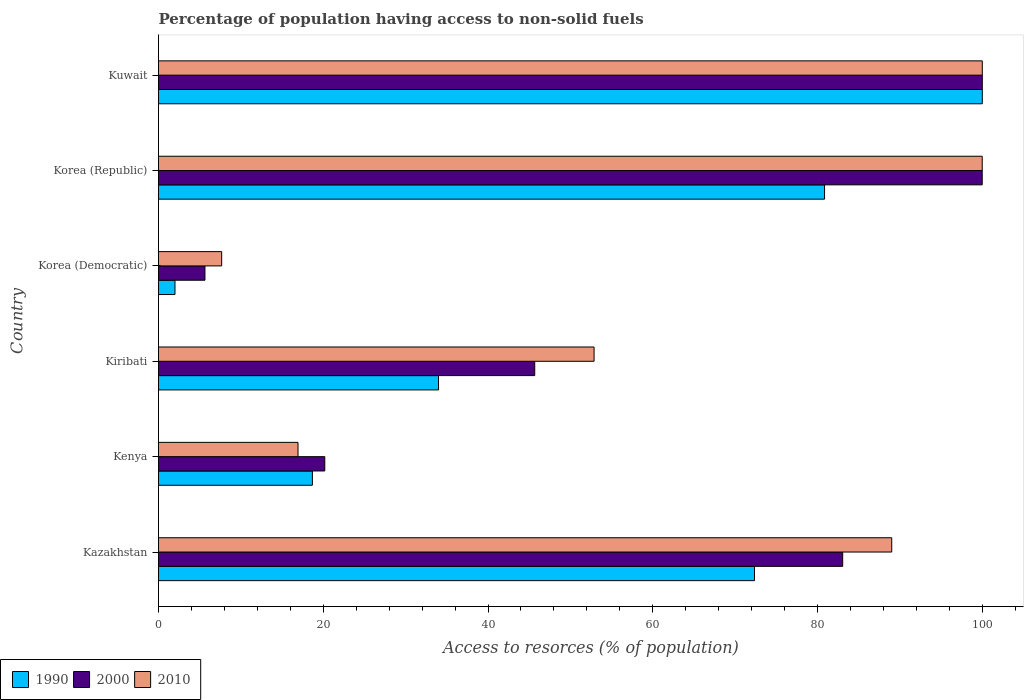How many different coloured bars are there?
Your answer should be compact. 3. How many groups of bars are there?
Your answer should be compact. 6. Are the number of bars on each tick of the Y-axis equal?
Offer a terse response. Yes. How many bars are there on the 2nd tick from the top?
Your answer should be very brief. 3. How many bars are there on the 1st tick from the bottom?
Offer a terse response. 3. What is the label of the 4th group of bars from the top?
Your answer should be very brief. Kiribati. In how many cases, is the number of bars for a given country not equal to the number of legend labels?
Offer a very short reply. 0. What is the percentage of population having access to non-solid fuels in 1990 in Kiribati?
Offer a terse response. 33.99. Across all countries, what is the maximum percentage of population having access to non-solid fuels in 1990?
Give a very brief answer. 100. Across all countries, what is the minimum percentage of population having access to non-solid fuels in 1990?
Give a very brief answer. 2. In which country was the percentage of population having access to non-solid fuels in 2000 maximum?
Make the answer very short. Kuwait. In which country was the percentage of population having access to non-solid fuels in 2000 minimum?
Ensure brevity in your answer.  Korea (Democratic). What is the total percentage of population having access to non-solid fuels in 2000 in the graph?
Make the answer very short. 354.53. What is the difference between the percentage of population having access to non-solid fuels in 2010 in Kazakhstan and that in Kiribati?
Offer a terse response. 36.13. What is the difference between the percentage of population having access to non-solid fuels in 1990 in Korea (Democratic) and the percentage of population having access to non-solid fuels in 2010 in Kuwait?
Keep it short and to the point. -98. What is the average percentage of population having access to non-solid fuels in 2010 per country?
Your response must be concise. 61.08. In how many countries, is the percentage of population having access to non-solid fuels in 2010 greater than 96 %?
Give a very brief answer. 2. What is the ratio of the percentage of population having access to non-solid fuels in 2000 in Korea (Republic) to that in Kuwait?
Offer a terse response. 1. Is the difference between the percentage of population having access to non-solid fuels in 2010 in Kiribati and Korea (Republic) greater than the difference between the percentage of population having access to non-solid fuels in 2000 in Kiribati and Korea (Republic)?
Keep it short and to the point. Yes. What is the difference between the highest and the second highest percentage of population having access to non-solid fuels in 1990?
Keep it short and to the point. 19.15. What is the difference between the highest and the lowest percentage of population having access to non-solid fuels in 2000?
Offer a terse response. 94.36. Is the sum of the percentage of population having access to non-solid fuels in 2010 in Kazakhstan and Korea (Democratic) greater than the maximum percentage of population having access to non-solid fuels in 1990 across all countries?
Your response must be concise. No. What is the difference between two consecutive major ticks on the X-axis?
Give a very brief answer. 20. How many legend labels are there?
Keep it short and to the point. 3. What is the title of the graph?
Offer a terse response. Percentage of population having access to non-solid fuels. What is the label or title of the X-axis?
Keep it short and to the point. Access to resorces (% of population). What is the label or title of the Y-axis?
Provide a succinct answer. Country. What is the Access to resorces (% of population) in 1990 in Kazakhstan?
Your answer should be compact. 72.35. What is the Access to resorces (% of population) of 2000 in Kazakhstan?
Ensure brevity in your answer.  83.05. What is the Access to resorces (% of population) of 2010 in Kazakhstan?
Provide a succinct answer. 89.01. What is the Access to resorces (% of population) of 1990 in Kenya?
Keep it short and to the point. 18.68. What is the Access to resorces (% of population) in 2000 in Kenya?
Provide a short and direct response. 20.18. What is the Access to resorces (% of population) of 2010 in Kenya?
Offer a very short reply. 16.93. What is the Access to resorces (% of population) of 1990 in Kiribati?
Provide a short and direct response. 33.99. What is the Access to resorces (% of population) in 2000 in Kiribati?
Make the answer very short. 45.67. What is the Access to resorces (% of population) of 2010 in Kiribati?
Make the answer very short. 52.87. What is the Access to resorces (% of population) in 1990 in Korea (Democratic)?
Offer a very short reply. 2. What is the Access to resorces (% of population) in 2000 in Korea (Democratic)?
Provide a short and direct response. 5.64. What is the Access to resorces (% of population) of 2010 in Korea (Democratic)?
Give a very brief answer. 7.67. What is the Access to resorces (% of population) of 1990 in Korea (Republic)?
Ensure brevity in your answer.  80.85. What is the Access to resorces (% of population) in 2000 in Korea (Republic)?
Your response must be concise. 99.99. What is the Access to resorces (% of population) in 2010 in Korea (Republic)?
Provide a short and direct response. 99.99. Across all countries, what is the minimum Access to resorces (% of population) of 1990?
Give a very brief answer. 2. Across all countries, what is the minimum Access to resorces (% of population) of 2000?
Make the answer very short. 5.64. Across all countries, what is the minimum Access to resorces (% of population) of 2010?
Provide a short and direct response. 7.67. What is the total Access to resorces (% of population) of 1990 in the graph?
Provide a succinct answer. 307.86. What is the total Access to resorces (% of population) of 2000 in the graph?
Provide a short and direct response. 354.53. What is the total Access to resorces (% of population) of 2010 in the graph?
Offer a very short reply. 366.47. What is the difference between the Access to resorces (% of population) of 1990 in Kazakhstan and that in Kenya?
Provide a succinct answer. 53.67. What is the difference between the Access to resorces (% of population) of 2000 in Kazakhstan and that in Kenya?
Keep it short and to the point. 62.87. What is the difference between the Access to resorces (% of population) of 2010 in Kazakhstan and that in Kenya?
Your answer should be compact. 72.07. What is the difference between the Access to resorces (% of population) in 1990 in Kazakhstan and that in Kiribati?
Provide a short and direct response. 38.36. What is the difference between the Access to resorces (% of population) in 2000 in Kazakhstan and that in Kiribati?
Make the answer very short. 37.38. What is the difference between the Access to resorces (% of population) of 2010 in Kazakhstan and that in Kiribati?
Give a very brief answer. 36.13. What is the difference between the Access to resorces (% of population) of 1990 in Kazakhstan and that in Korea (Democratic)?
Offer a terse response. 70.35. What is the difference between the Access to resorces (% of population) of 2000 in Kazakhstan and that in Korea (Democratic)?
Your answer should be compact. 77.41. What is the difference between the Access to resorces (% of population) of 2010 in Kazakhstan and that in Korea (Democratic)?
Provide a short and direct response. 81.34. What is the difference between the Access to resorces (% of population) in 1990 in Kazakhstan and that in Korea (Republic)?
Make the answer very short. -8.5. What is the difference between the Access to resorces (% of population) of 2000 in Kazakhstan and that in Korea (Republic)?
Provide a short and direct response. -16.94. What is the difference between the Access to resorces (% of population) of 2010 in Kazakhstan and that in Korea (Republic)?
Your answer should be very brief. -10.98. What is the difference between the Access to resorces (% of population) in 1990 in Kazakhstan and that in Kuwait?
Provide a short and direct response. -27.65. What is the difference between the Access to resorces (% of population) in 2000 in Kazakhstan and that in Kuwait?
Give a very brief answer. -16.95. What is the difference between the Access to resorces (% of population) of 2010 in Kazakhstan and that in Kuwait?
Give a very brief answer. -10.99. What is the difference between the Access to resorces (% of population) in 1990 in Kenya and that in Kiribati?
Offer a terse response. -15.31. What is the difference between the Access to resorces (% of population) of 2000 in Kenya and that in Kiribati?
Keep it short and to the point. -25.48. What is the difference between the Access to resorces (% of population) in 2010 in Kenya and that in Kiribati?
Offer a very short reply. -35.94. What is the difference between the Access to resorces (% of population) of 1990 in Kenya and that in Korea (Democratic)?
Your answer should be compact. 16.68. What is the difference between the Access to resorces (% of population) of 2000 in Kenya and that in Korea (Democratic)?
Your answer should be very brief. 14.55. What is the difference between the Access to resorces (% of population) in 2010 in Kenya and that in Korea (Democratic)?
Keep it short and to the point. 9.27. What is the difference between the Access to resorces (% of population) in 1990 in Kenya and that in Korea (Republic)?
Your response must be concise. -62.17. What is the difference between the Access to resorces (% of population) of 2000 in Kenya and that in Korea (Republic)?
Keep it short and to the point. -79.81. What is the difference between the Access to resorces (% of population) in 2010 in Kenya and that in Korea (Republic)?
Your response must be concise. -83.06. What is the difference between the Access to resorces (% of population) of 1990 in Kenya and that in Kuwait?
Your response must be concise. -81.32. What is the difference between the Access to resorces (% of population) of 2000 in Kenya and that in Kuwait?
Your answer should be compact. -79.82. What is the difference between the Access to resorces (% of population) in 2010 in Kenya and that in Kuwait?
Provide a short and direct response. -83.07. What is the difference between the Access to resorces (% of population) of 1990 in Kiribati and that in Korea (Democratic)?
Make the answer very short. 31.99. What is the difference between the Access to resorces (% of population) in 2000 in Kiribati and that in Korea (Democratic)?
Ensure brevity in your answer.  40.03. What is the difference between the Access to resorces (% of population) in 2010 in Kiribati and that in Korea (Democratic)?
Your answer should be very brief. 45.21. What is the difference between the Access to resorces (% of population) in 1990 in Kiribati and that in Korea (Republic)?
Offer a terse response. -46.86. What is the difference between the Access to resorces (% of population) in 2000 in Kiribati and that in Korea (Republic)?
Offer a terse response. -54.32. What is the difference between the Access to resorces (% of population) in 2010 in Kiribati and that in Korea (Republic)?
Provide a short and direct response. -47.12. What is the difference between the Access to resorces (% of population) in 1990 in Kiribati and that in Kuwait?
Keep it short and to the point. -66.01. What is the difference between the Access to resorces (% of population) of 2000 in Kiribati and that in Kuwait?
Give a very brief answer. -54.33. What is the difference between the Access to resorces (% of population) of 2010 in Kiribati and that in Kuwait?
Offer a terse response. -47.13. What is the difference between the Access to resorces (% of population) of 1990 in Korea (Democratic) and that in Korea (Republic)?
Your answer should be compact. -78.85. What is the difference between the Access to resorces (% of population) of 2000 in Korea (Democratic) and that in Korea (Republic)?
Ensure brevity in your answer.  -94.35. What is the difference between the Access to resorces (% of population) of 2010 in Korea (Democratic) and that in Korea (Republic)?
Your answer should be very brief. -92.32. What is the difference between the Access to resorces (% of population) in 1990 in Korea (Democratic) and that in Kuwait?
Give a very brief answer. -98. What is the difference between the Access to resorces (% of population) in 2000 in Korea (Democratic) and that in Kuwait?
Offer a very short reply. -94.36. What is the difference between the Access to resorces (% of population) of 2010 in Korea (Democratic) and that in Kuwait?
Offer a very short reply. -92.33. What is the difference between the Access to resorces (% of population) in 1990 in Korea (Republic) and that in Kuwait?
Your answer should be compact. -19.15. What is the difference between the Access to resorces (% of population) in 2000 in Korea (Republic) and that in Kuwait?
Your answer should be compact. -0.01. What is the difference between the Access to resorces (% of population) in 2010 in Korea (Republic) and that in Kuwait?
Keep it short and to the point. -0.01. What is the difference between the Access to resorces (% of population) of 1990 in Kazakhstan and the Access to resorces (% of population) of 2000 in Kenya?
Ensure brevity in your answer.  52.16. What is the difference between the Access to resorces (% of population) of 1990 in Kazakhstan and the Access to resorces (% of population) of 2010 in Kenya?
Your response must be concise. 55.41. What is the difference between the Access to resorces (% of population) of 2000 in Kazakhstan and the Access to resorces (% of population) of 2010 in Kenya?
Your response must be concise. 66.12. What is the difference between the Access to resorces (% of population) of 1990 in Kazakhstan and the Access to resorces (% of population) of 2000 in Kiribati?
Your answer should be compact. 26.68. What is the difference between the Access to resorces (% of population) in 1990 in Kazakhstan and the Access to resorces (% of population) in 2010 in Kiribati?
Your answer should be very brief. 19.47. What is the difference between the Access to resorces (% of population) in 2000 in Kazakhstan and the Access to resorces (% of population) in 2010 in Kiribati?
Keep it short and to the point. 30.18. What is the difference between the Access to resorces (% of population) in 1990 in Kazakhstan and the Access to resorces (% of population) in 2000 in Korea (Democratic)?
Your answer should be compact. 66.71. What is the difference between the Access to resorces (% of population) of 1990 in Kazakhstan and the Access to resorces (% of population) of 2010 in Korea (Democratic)?
Ensure brevity in your answer.  64.68. What is the difference between the Access to resorces (% of population) in 2000 in Kazakhstan and the Access to resorces (% of population) in 2010 in Korea (Democratic)?
Offer a terse response. 75.39. What is the difference between the Access to resorces (% of population) of 1990 in Kazakhstan and the Access to resorces (% of population) of 2000 in Korea (Republic)?
Offer a terse response. -27.64. What is the difference between the Access to resorces (% of population) of 1990 in Kazakhstan and the Access to resorces (% of population) of 2010 in Korea (Republic)?
Provide a short and direct response. -27.64. What is the difference between the Access to resorces (% of population) in 2000 in Kazakhstan and the Access to resorces (% of population) in 2010 in Korea (Republic)?
Provide a short and direct response. -16.94. What is the difference between the Access to resorces (% of population) of 1990 in Kazakhstan and the Access to resorces (% of population) of 2000 in Kuwait?
Your response must be concise. -27.65. What is the difference between the Access to resorces (% of population) of 1990 in Kazakhstan and the Access to resorces (% of population) of 2010 in Kuwait?
Your answer should be very brief. -27.65. What is the difference between the Access to resorces (% of population) of 2000 in Kazakhstan and the Access to resorces (% of population) of 2010 in Kuwait?
Make the answer very short. -16.95. What is the difference between the Access to resorces (% of population) of 1990 in Kenya and the Access to resorces (% of population) of 2000 in Kiribati?
Your answer should be compact. -26.99. What is the difference between the Access to resorces (% of population) of 1990 in Kenya and the Access to resorces (% of population) of 2010 in Kiribati?
Keep it short and to the point. -34.19. What is the difference between the Access to resorces (% of population) of 2000 in Kenya and the Access to resorces (% of population) of 2010 in Kiribati?
Ensure brevity in your answer.  -32.69. What is the difference between the Access to resorces (% of population) in 1990 in Kenya and the Access to resorces (% of population) in 2000 in Korea (Democratic)?
Offer a terse response. 13.04. What is the difference between the Access to resorces (% of population) in 1990 in Kenya and the Access to resorces (% of population) in 2010 in Korea (Democratic)?
Provide a succinct answer. 11.01. What is the difference between the Access to resorces (% of population) of 2000 in Kenya and the Access to resorces (% of population) of 2010 in Korea (Democratic)?
Make the answer very short. 12.52. What is the difference between the Access to resorces (% of population) in 1990 in Kenya and the Access to resorces (% of population) in 2000 in Korea (Republic)?
Ensure brevity in your answer.  -81.31. What is the difference between the Access to resorces (% of population) of 1990 in Kenya and the Access to resorces (% of population) of 2010 in Korea (Republic)?
Your response must be concise. -81.31. What is the difference between the Access to resorces (% of population) of 2000 in Kenya and the Access to resorces (% of population) of 2010 in Korea (Republic)?
Provide a succinct answer. -79.81. What is the difference between the Access to resorces (% of population) of 1990 in Kenya and the Access to resorces (% of population) of 2000 in Kuwait?
Your answer should be very brief. -81.32. What is the difference between the Access to resorces (% of population) of 1990 in Kenya and the Access to resorces (% of population) of 2010 in Kuwait?
Give a very brief answer. -81.32. What is the difference between the Access to resorces (% of population) of 2000 in Kenya and the Access to resorces (% of population) of 2010 in Kuwait?
Offer a very short reply. -79.82. What is the difference between the Access to resorces (% of population) in 1990 in Kiribati and the Access to resorces (% of population) in 2000 in Korea (Democratic)?
Provide a succinct answer. 28.35. What is the difference between the Access to resorces (% of population) of 1990 in Kiribati and the Access to resorces (% of population) of 2010 in Korea (Democratic)?
Your response must be concise. 26.32. What is the difference between the Access to resorces (% of population) of 2000 in Kiribati and the Access to resorces (% of population) of 2010 in Korea (Democratic)?
Make the answer very short. 38. What is the difference between the Access to resorces (% of population) in 1990 in Kiribati and the Access to resorces (% of population) in 2000 in Korea (Republic)?
Offer a very short reply. -66. What is the difference between the Access to resorces (% of population) in 1990 in Kiribati and the Access to resorces (% of population) in 2010 in Korea (Republic)?
Provide a succinct answer. -66. What is the difference between the Access to resorces (% of population) of 2000 in Kiribati and the Access to resorces (% of population) of 2010 in Korea (Republic)?
Ensure brevity in your answer.  -54.32. What is the difference between the Access to resorces (% of population) in 1990 in Kiribati and the Access to resorces (% of population) in 2000 in Kuwait?
Provide a succinct answer. -66.01. What is the difference between the Access to resorces (% of population) in 1990 in Kiribati and the Access to resorces (% of population) in 2010 in Kuwait?
Keep it short and to the point. -66.01. What is the difference between the Access to resorces (% of population) of 2000 in Kiribati and the Access to resorces (% of population) of 2010 in Kuwait?
Keep it short and to the point. -54.33. What is the difference between the Access to resorces (% of population) in 1990 in Korea (Democratic) and the Access to resorces (% of population) in 2000 in Korea (Republic)?
Your answer should be very brief. -97.99. What is the difference between the Access to resorces (% of population) of 1990 in Korea (Democratic) and the Access to resorces (% of population) of 2010 in Korea (Republic)?
Provide a succinct answer. -97.99. What is the difference between the Access to resorces (% of population) of 2000 in Korea (Democratic) and the Access to resorces (% of population) of 2010 in Korea (Republic)?
Provide a succinct answer. -94.35. What is the difference between the Access to resorces (% of population) of 1990 in Korea (Democratic) and the Access to resorces (% of population) of 2000 in Kuwait?
Offer a terse response. -98. What is the difference between the Access to resorces (% of population) of 1990 in Korea (Democratic) and the Access to resorces (% of population) of 2010 in Kuwait?
Keep it short and to the point. -98. What is the difference between the Access to resorces (% of population) of 2000 in Korea (Democratic) and the Access to resorces (% of population) of 2010 in Kuwait?
Keep it short and to the point. -94.36. What is the difference between the Access to resorces (% of population) in 1990 in Korea (Republic) and the Access to resorces (% of population) in 2000 in Kuwait?
Give a very brief answer. -19.15. What is the difference between the Access to resorces (% of population) in 1990 in Korea (Republic) and the Access to resorces (% of population) in 2010 in Kuwait?
Offer a very short reply. -19.15. What is the difference between the Access to resorces (% of population) in 2000 in Korea (Republic) and the Access to resorces (% of population) in 2010 in Kuwait?
Your answer should be compact. -0.01. What is the average Access to resorces (% of population) in 1990 per country?
Give a very brief answer. 51.31. What is the average Access to resorces (% of population) in 2000 per country?
Provide a succinct answer. 59.09. What is the average Access to resorces (% of population) of 2010 per country?
Your answer should be compact. 61.08. What is the difference between the Access to resorces (% of population) in 1990 and Access to resorces (% of population) in 2000 in Kazakhstan?
Ensure brevity in your answer.  -10.71. What is the difference between the Access to resorces (% of population) of 1990 and Access to resorces (% of population) of 2010 in Kazakhstan?
Your response must be concise. -16.66. What is the difference between the Access to resorces (% of population) in 2000 and Access to resorces (% of population) in 2010 in Kazakhstan?
Keep it short and to the point. -5.95. What is the difference between the Access to resorces (% of population) of 1990 and Access to resorces (% of population) of 2000 in Kenya?
Make the answer very short. -1.51. What is the difference between the Access to resorces (% of population) in 1990 and Access to resorces (% of population) in 2010 in Kenya?
Provide a short and direct response. 1.74. What is the difference between the Access to resorces (% of population) in 2000 and Access to resorces (% of population) in 2010 in Kenya?
Your response must be concise. 3.25. What is the difference between the Access to resorces (% of population) in 1990 and Access to resorces (% of population) in 2000 in Kiribati?
Offer a terse response. -11.68. What is the difference between the Access to resorces (% of population) in 1990 and Access to resorces (% of population) in 2010 in Kiribati?
Your answer should be compact. -18.88. What is the difference between the Access to resorces (% of population) in 2000 and Access to resorces (% of population) in 2010 in Kiribati?
Offer a terse response. -7.2. What is the difference between the Access to resorces (% of population) of 1990 and Access to resorces (% of population) of 2000 in Korea (Democratic)?
Your answer should be compact. -3.64. What is the difference between the Access to resorces (% of population) of 1990 and Access to resorces (% of population) of 2010 in Korea (Democratic)?
Provide a short and direct response. -5.67. What is the difference between the Access to resorces (% of population) of 2000 and Access to resorces (% of population) of 2010 in Korea (Democratic)?
Offer a very short reply. -2.03. What is the difference between the Access to resorces (% of population) in 1990 and Access to resorces (% of population) in 2000 in Korea (Republic)?
Provide a short and direct response. -19.14. What is the difference between the Access to resorces (% of population) in 1990 and Access to resorces (% of population) in 2010 in Korea (Republic)?
Your response must be concise. -19.14. What is the difference between the Access to resorces (% of population) of 1990 and Access to resorces (% of population) of 2010 in Kuwait?
Ensure brevity in your answer.  0. What is the ratio of the Access to resorces (% of population) of 1990 in Kazakhstan to that in Kenya?
Your answer should be very brief. 3.87. What is the ratio of the Access to resorces (% of population) of 2000 in Kazakhstan to that in Kenya?
Make the answer very short. 4.11. What is the ratio of the Access to resorces (% of population) in 2010 in Kazakhstan to that in Kenya?
Offer a terse response. 5.26. What is the ratio of the Access to resorces (% of population) in 1990 in Kazakhstan to that in Kiribati?
Ensure brevity in your answer.  2.13. What is the ratio of the Access to resorces (% of population) in 2000 in Kazakhstan to that in Kiribati?
Your answer should be compact. 1.82. What is the ratio of the Access to resorces (% of population) of 2010 in Kazakhstan to that in Kiribati?
Provide a succinct answer. 1.68. What is the ratio of the Access to resorces (% of population) of 1990 in Kazakhstan to that in Korea (Democratic)?
Provide a succinct answer. 36.17. What is the ratio of the Access to resorces (% of population) of 2000 in Kazakhstan to that in Korea (Democratic)?
Provide a succinct answer. 14.73. What is the ratio of the Access to resorces (% of population) of 2010 in Kazakhstan to that in Korea (Democratic)?
Ensure brevity in your answer.  11.61. What is the ratio of the Access to resorces (% of population) of 1990 in Kazakhstan to that in Korea (Republic)?
Provide a succinct answer. 0.89. What is the ratio of the Access to resorces (% of population) in 2000 in Kazakhstan to that in Korea (Republic)?
Your answer should be very brief. 0.83. What is the ratio of the Access to resorces (% of population) of 2010 in Kazakhstan to that in Korea (Republic)?
Your answer should be very brief. 0.89. What is the ratio of the Access to resorces (% of population) of 1990 in Kazakhstan to that in Kuwait?
Keep it short and to the point. 0.72. What is the ratio of the Access to resorces (% of population) of 2000 in Kazakhstan to that in Kuwait?
Give a very brief answer. 0.83. What is the ratio of the Access to resorces (% of population) of 2010 in Kazakhstan to that in Kuwait?
Keep it short and to the point. 0.89. What is the ratio of the Access to resorces (% of population) of 1990 in Kenya to that in Kiribati?
Make the answer very short. 0.55. What is the ratio of the Access to resorces (% of population) in 2000 in Kenya to that in Kiribati?
Ensure brevity in your answer.  0.44. What is the ratio of the Access to resorces (% of population) in 2010 in Kenya to that in Kiribati?
Your response must be concise. 0.32. What is the ratio of the Access to resorces (% of population) of 1990 in Kenya to that in Korea (Democratic)?
Your response must be concise. 9.34. What is the ratio of the Access to resorces (% of population) of 2000 in Kenya to that in Korea (Democratic)?
Offer a very short reply. 3.58. What is the ratio of the Access to resorces (% of population) of 2010 in Kenya to that in Korea (Democratic)?
Your response must be concise. 2.21. What is the ratio of the Access to resorces (% of population) of 1990 in Kenya to that in Korea (Republic)?
Ensure brevity in your answer.  0.23. What is the ratio of the Access to resorces (% of population) of 2000 in Kenya to that in Korea (Republic)?
Provide a short and direct response. 0.2. What is the ratio of the Access to resorces (% of population) in 2010 in Kenya to that in Korea (Republic)?
Provide a short and direct response. 0.17. What is the ratio of the Access to resorces (% of population) in 1990 in Kenya to that in Kuwait?
Your response must be concise. 0.19. What is the ratio of the Access to resorces (% of population) in 2000 in Kenya to that in Kuwait?
Make the answer very short. 0.2. What is the ratio of the Access to resorces (% of population) in 2010 in Kenya to that in Kuwait?
Your answer should be compact. 0.17. What is the ratio of the Access to resorces (% of population) in 1990 in Kiribati to that in Korea (Democratic)?
Keep it short and to the point. 17. What is the ratio of the Access to resorces (% of population) in 2000 in Kiribati to that in Korea (Democratic)?
Your answer should be compact. 8.1. What is the ratio of the Access to resorces (% of population) of 2010 in Kiribati to that in Korea (Democratic)?
Ensure brevity in your answer.  6.9. What is the ratio of the Access to resorces (% of population) in 1990 in Kiribati to that in Korea (Republic)?
Your response must be concise. 0.42. What is the ratio of the Access to resorces (% of population) in 2000 in Kiribati to that in Korea (Republic)?
Make the answer very short. 0.46. What is the ratio of the Access to resorces (% of population) of 2010 in Kiribati to that in Korea (Republic)?
Your response must be concise. 0.53. What is the ratio of the Access to resorces (% of population) of 1990 in Kiribati to that in Kuwait?
Make the answer very short. 0.34. What is the ratio of the Access to resorces (% of population) in 2000 in Kiribati to that in Kuwait?
Offer a very short reply. 0.46. What is the ratio of the Access to resorces (% of population) in 2010 in Kiribati to that in Kuwait?
Your response must be concise. 0.53. What is the ratio of the Access to resorces (% of population) of 1990 in Korea (Democratic) to that in Korea (Republic)?
Keep it short and to the point. 0.02. What is the ratio of the Access to resorces (% of population) of 2000 in Korea (Democratic) to that in Korea (Republic)?
Make the answer very short. 0.06. What is the ratio of the Access to resorces (% of population) of 2010 in Korea (Democratic) to that in Korea (Republic)?
Your response must be concise. 0.08. What is the ratio of the Access to resorces (% of population) of 2000 in Korea (Democratic) to that in Kuwait?
Give a very brief answer. 0.06. What is the ratio of the Access to resorces (% of population) of 2010 in Korea (Democratic) to that in Kuwait?
Keep it short and to the point. 0.08. What is the ratio of the Access to resorces (% of population) in 1990 in Korea (Republic) to that in Kuwait?
Provide a short and direct response. 0.81. What is the ratio of the Access to resorces (% of population) in 2000 in Korea (Republic) to that in Kuwait?
Give a very brief answer. 1. What is the ratio of the Access to resorces (% of population) in 2010 in Korea (Republic) to that in Kuwait?
Ensure brevity in your answer.  1. What is the difference between the highest and the second highest Access to resorces (% of population) of 1990?
Offer a very short reply. 19.15. What is the difference between the highest and the lowest Access to resorces (% of population) of 2000?
Your answer should be compact. 94.36. What is the difference between the highest and the lowest Access to resorces (% of population) of 2010?
Offer a terse response. 92.33. 